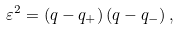Convert formula to latex. <formula><loc_0><loc_0><loc_500><loc_500>\varepsilon ^ { 2 } = \left ( q - q _ { + } \right ) \left ( q - q _ { - } \right ) ,</formula> 